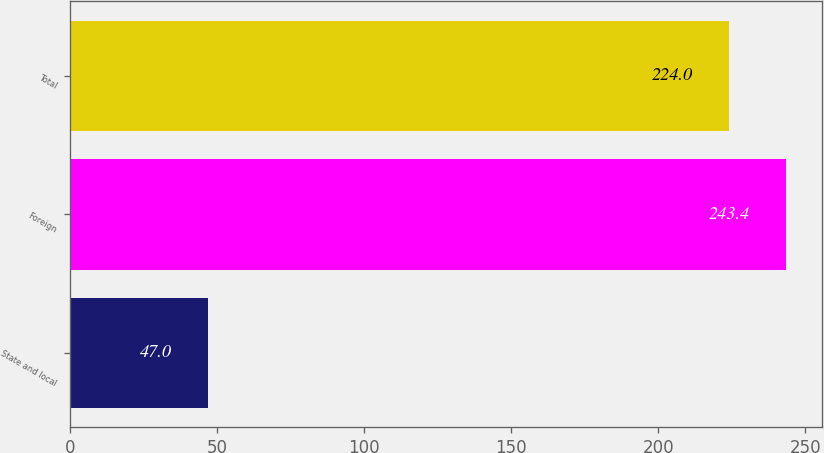Convert chart to OTSL. <chart><loc_0><loc_0><loc_500><loc_500><bar_chart><fcel>State and local<fcel>Foreign<fcel>Total<nl><fcel>47<fcel>243.4<fcel>224<nl></chart> 